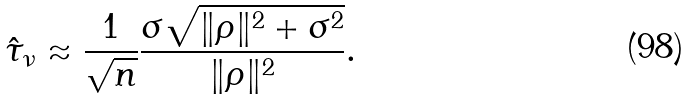Convert formula to latex. <formula><loc_0><loc_0><loc_500><loc_500>\hat { \tau } _ { \nu } \approx \frac { 1 } { \sqrt { n } } \frac { \sigma \sqrt { \| \rho \| ^ { 2 } + \sigma ^ { 2 } } } { \| \rho \| ^ { 2 } } .</formula> 